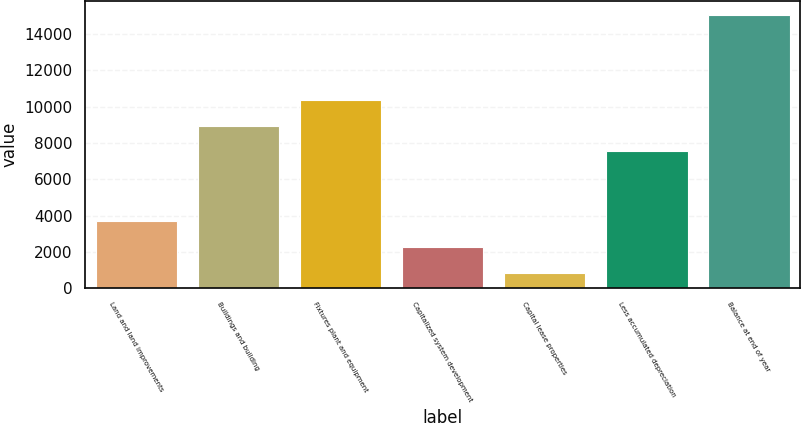Convert chart. <chart><loc_0><loc_0><loc_500><loc_500><bar_chart><fcel>Land and land improvements<fcel>Buildings and building<fcel>Fixtures plant and equipment<fcel>Capitalized system development<fcel>Capital lease properties<fcel>Less accumulated depreciation<fcel>Balance at end of year<nl><fcel>3687<fcel>8964.7<fcel>10389.4<fcel>2245.7<fcel>821<fcel>7540<fcel>15068<nl></chart> 